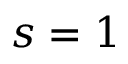Convert formula to latex. <formula><loc_0><loc_0><loc_500><loc_500>s = 1</formula> 